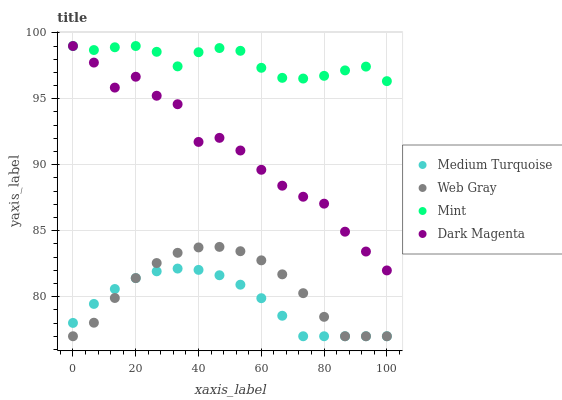Does Medium Turquoise have the minimum area under the curve?
Answer yes or no. Yes. Does Mint have the maximum area under the curve?
Answer yes or no. Yes. Does Dark Magenta have the minimum area under the curve?
Answer yes or no. No. Does Dark Magenta have the maximum area under the curve?
Answer yes or no. No. Is Medium Turquoise the smoothest?
Answer yes or no. Yes. Is Dark Magenta the roughest?
Answer yes or no. Yes. Is Mint the smoothest?
Answer yes or no. No. Is Mint the roughest?
Answer yes or no. No. Does Web Gray have the lowest value?
Answer yes or no. Yes. Does Dark Magenta have the lowest value?
Answer yes or no. No. Does Dark Magenta have the highest value?
Answer yes or no. Yes. Does Medium Turquoise have the highest value?
Answer yes or no. No. Is Medium Turquoise less than Mint?
Answer yes or no. Yes. Is Dark Magenta greater than Medium Turquoise?
Answer yes or no. Yes. Does Dark Magenta intersect Mint?
Answer yes or no. Yes. Is Dark Magenta less than Mint?
Answer yes or no. No. Is Dark Magenta greater than Mint?
Answer yes or no. No. Does Medium Turquoise intersect Mint?
Answer yes or no. No. 